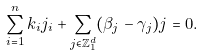<formula> <loc_0><loc_0><loc_500><loc_500>\sum _ { i = 1 } ^ { n } k _ { i } j _ { i } + \sum _ { j \in \mathbb { Z } _ { 1 } ^ { d } } ( \beta _ { j } - \gamma _ { j } ) j = 0 .</formula> 